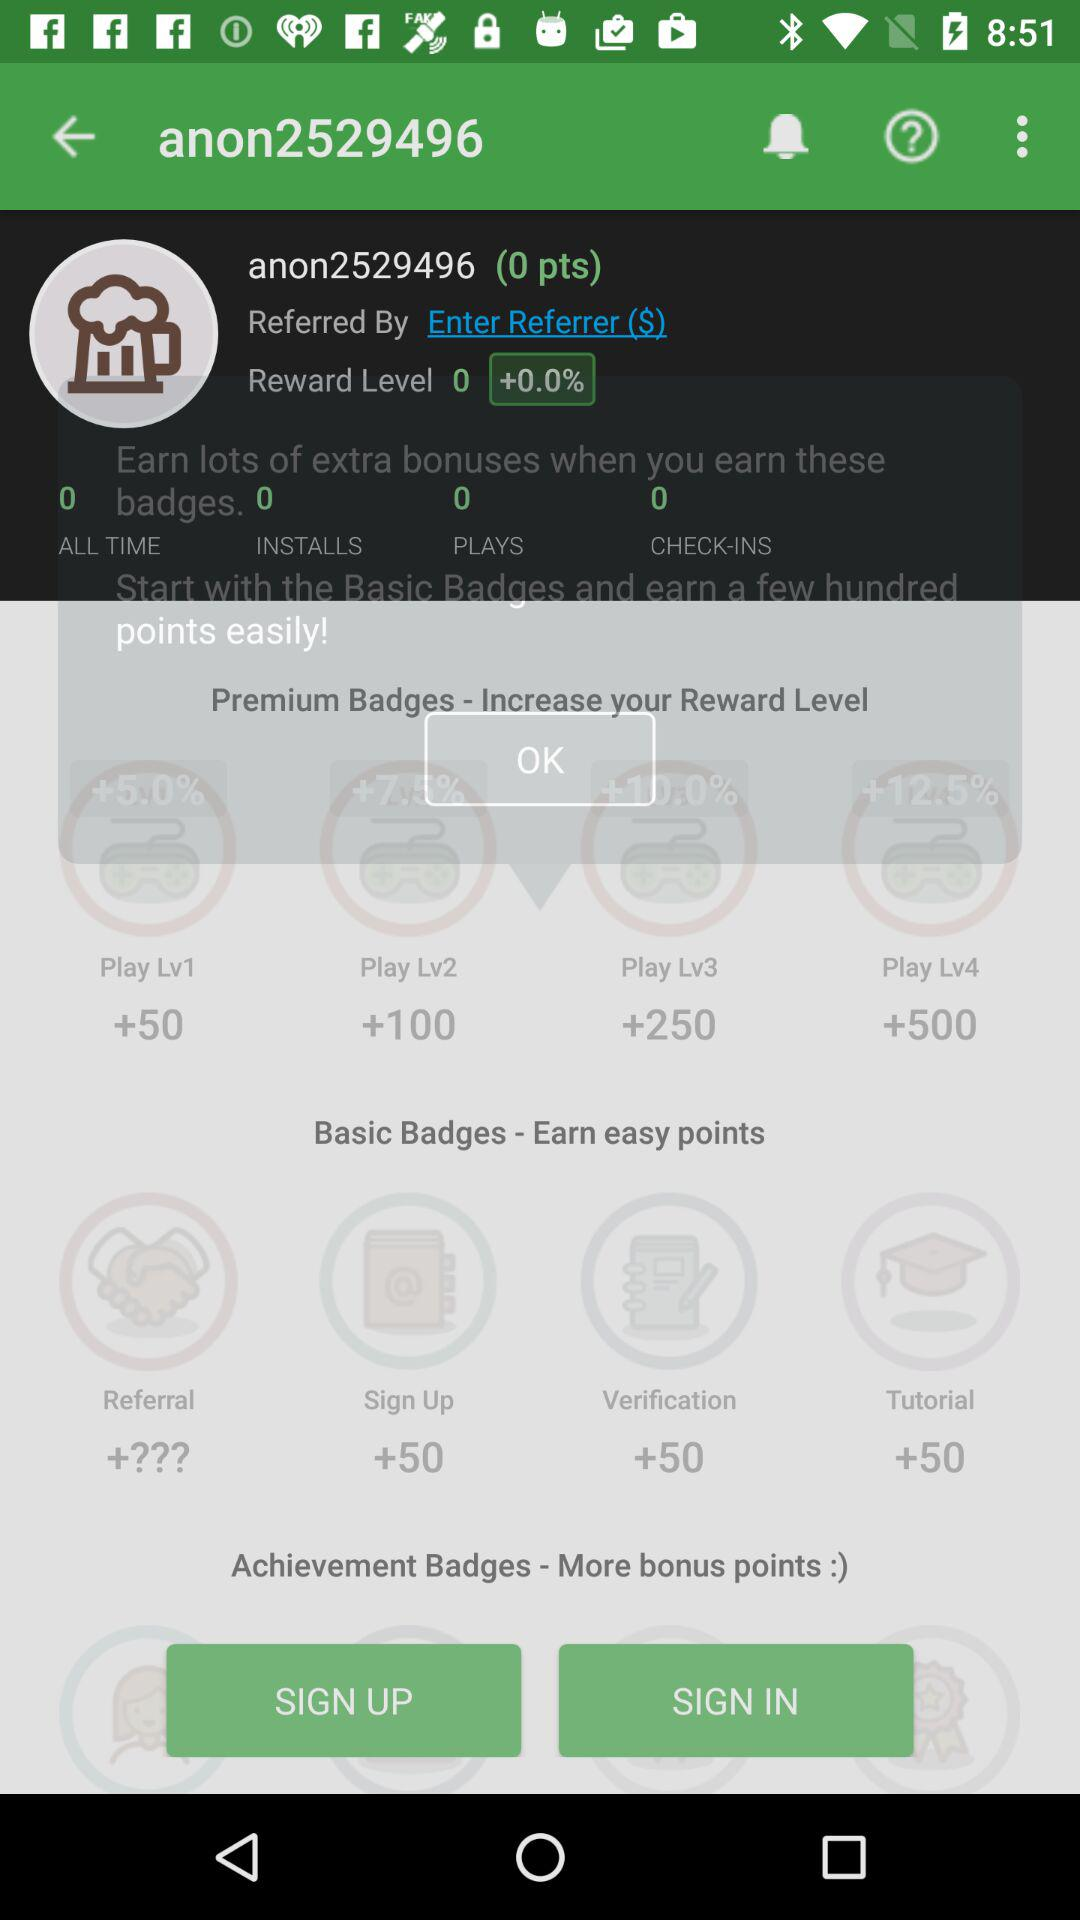How many points are earned for completing the verification badge?
Answer the question using a single word or phrase. 50 